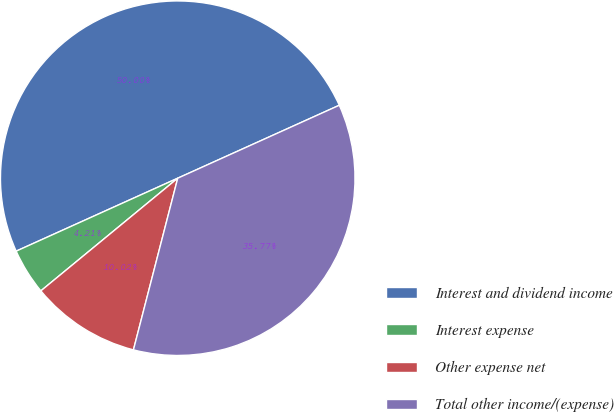Convert chart to OTSL. <chart><loc_0><loc_0><loc_500><loc_500><pie_chart><fcel>Interest and dividend income<fcel>Interest expense<fcel>Other expense net<fcel>Total other income/(expense)<nl><fcel>50.0%<fcel>4.21%<fcel>10.02%<fcel>35.77%<nl></chart> 